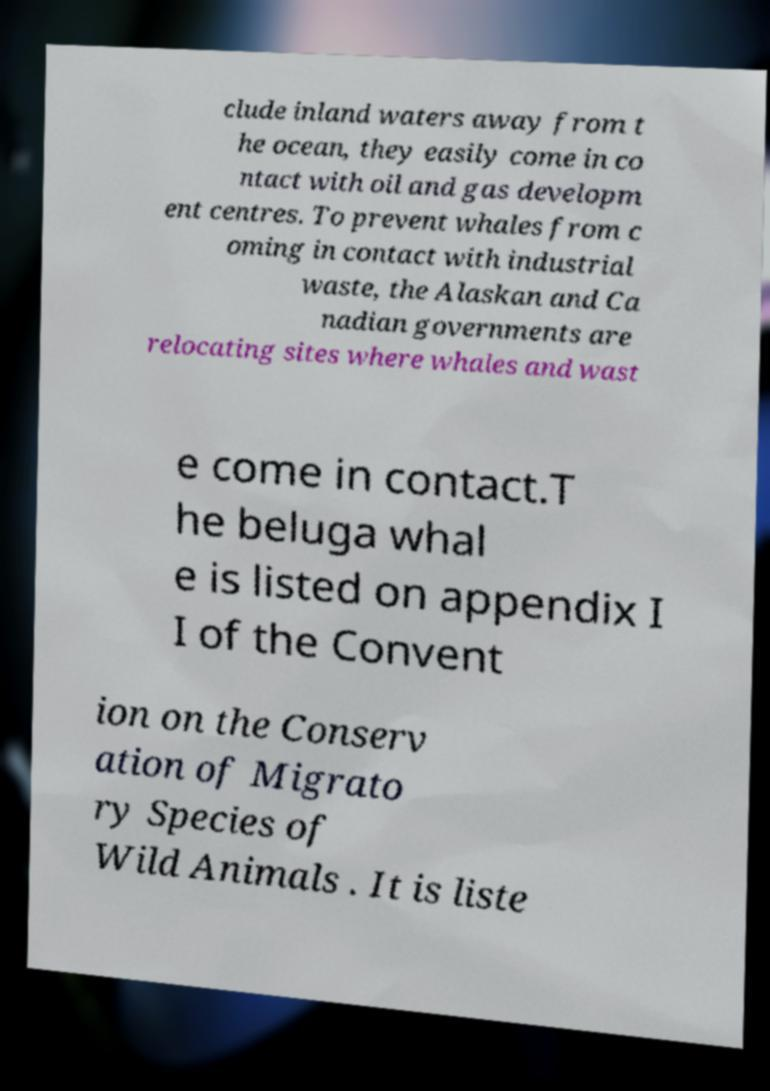Could you assist in decoding the text presented in this image and type it out clearly? clude inland waters away from t he ocean, they easily come in co ntact with oil and gas developm ent centres. To prevent whales from c oming in contact with industrial waste, the Alaskan and Ca nadian governments are relocating sites where whales and wast e come in contact.T he beluga whal e is listed on appendix I I of the Convent ion on the Conserv ation of Migrato ry Species of Wild Animals . It is liste 